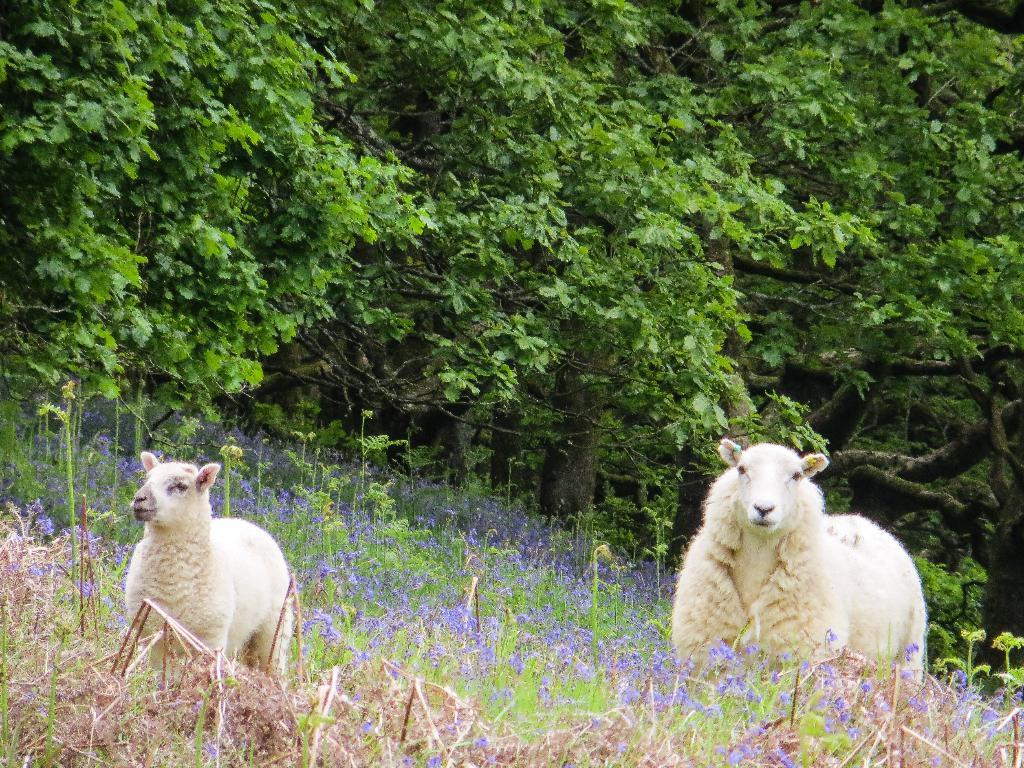What type of animals are in the image? There are two cream-colored animals in the image. Where are the animals located? The animals are on the grass. What can be seen growing on the grass? There are purple flowers on the grass. What is visible in the background of the image? There are many trees in the background of the image. What type of offer is being made by the animals in the image? There is no indication in the image that the animals are making any offer. 